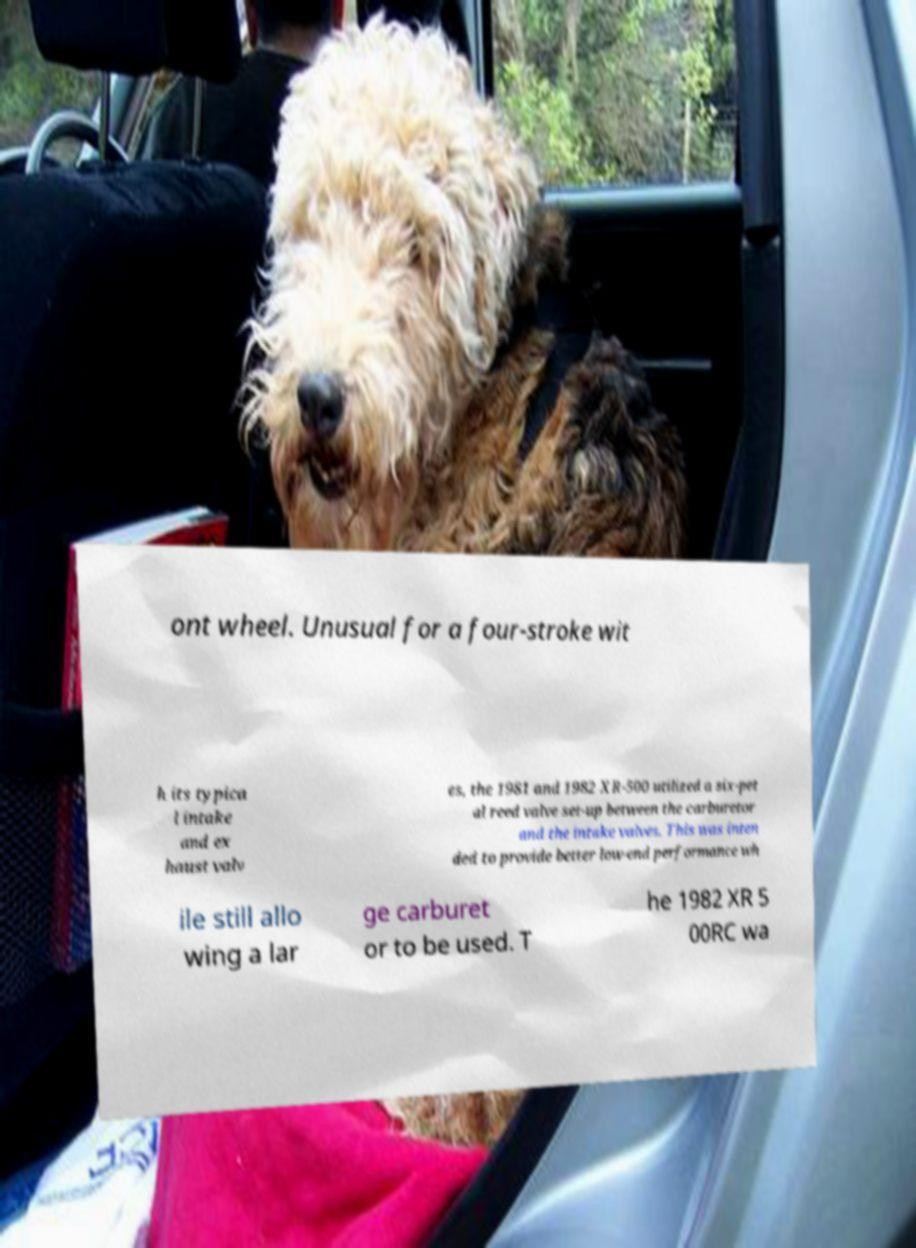Can you accurately transcribe the text from the provided image for me? ont wheel. Unusual for a four-stroke wit h its typica l intake and ex haust valv es, the 1981 and 1982 XR-500 utilized a six-pet al reed valve set-up between the carburetor and the intake valves. This was inten ded to provide better low-end performance wh ile still allo wing a lar ge carburet or to be used. T he 1982 XR 5 00RC wa 